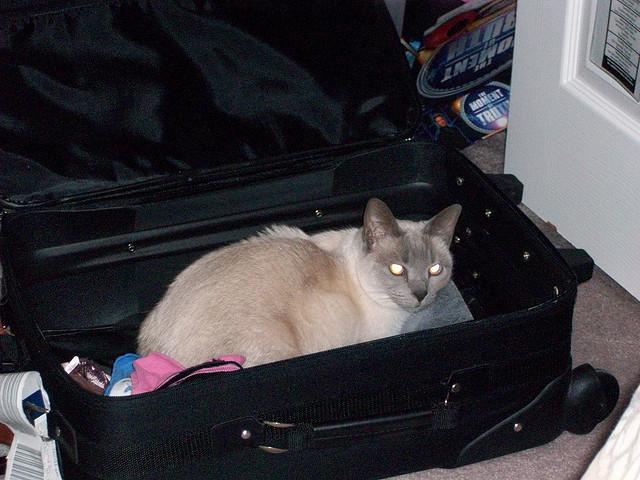What breed of cat is this?
Answer briefly. Siamese. Is this a cat bed?
Answer briefly. No. What color are the eyes?
Give a very brief answer. Yellow. 